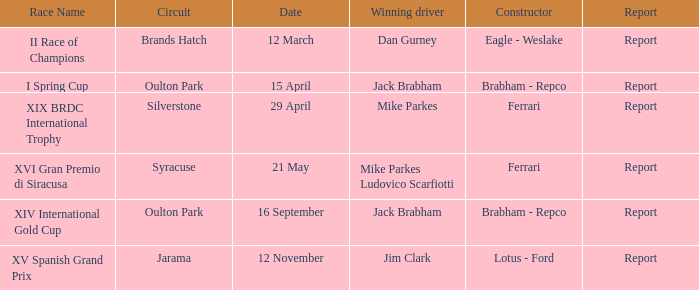What is the name of the race on 16 september? XIV International Gold Cup. 